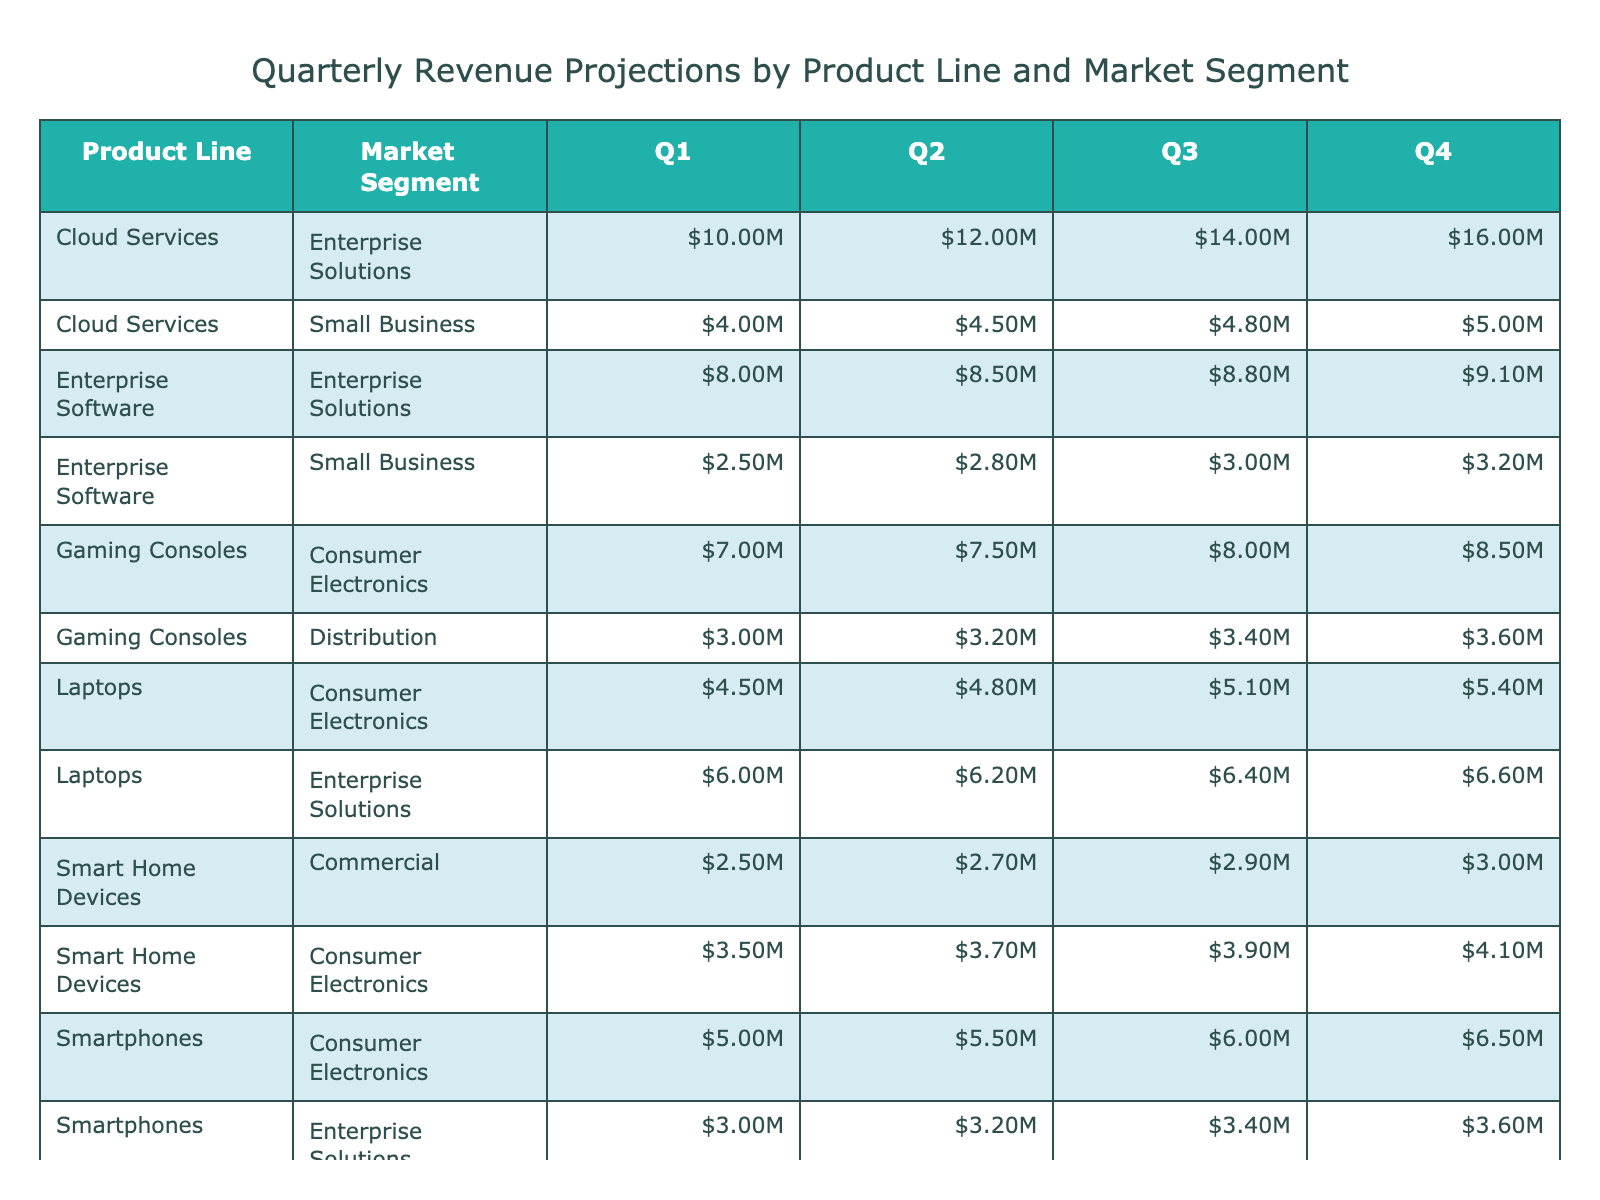What is the projected revenue for Smartphones in Q3? The table shows that the revenue for Smartphones in Q3 is listed under the respective market segments. For Consumer Electronics, it's $6.00M, and for Enterprise Solutions, it's $3.40M.
Answer: $6.00M (Consumer Electronics), $3.40M (Enterprise Solutions) Which product line has the highest total projected revenue across all quarters? To determine this, we can add the revenues for each product line across all quarters. The total revenues are: Smartphones = $23.00M, Laptops = $23.00M, Wearable Devices = $9.80M, Smart Home Devices = $9.60M, Cloud Services = $61.00M, Gaming Consoles = $33.00M, Enterprise Software = $32.00M. Cloud Services has the highest total at $61.00M.
Answer: Cloud Services Is the revenue for Wearable Devices in Q2 higher than that of Gaming Consoles in Q1? The revenue for Wearable Devices in Q2 is $2.30M, while Gaming Consoles in Q1 is $7.00M. Comparing the two, Wearable Devices’ $2.30M is less than Gaming Consoles’ $7.00M.
Answer: No What is the average projected revenue for Laptops across the four quarters? First, we sum the revenues for Laptops across the four quarters: $4.50M + $4.80M + $5.10M + $5.40M = $20.80M. Then, we divide by the number of quarters (4), resulting in an average of $5.20M.
Answer: $5.20M Which market segment contributes the least revenue for the Smart Home Devices product line? The table shows that Smart Home Devices has two market segments: Consumer Electronics with $15.70M total and Commercial with $11.80M total across all quarters. The Commercial segment contributes less.
Answer: Commercial What was the revenue difference between Q1 and Q4 for Cloud Services? For Q1, Cloud Services has a revenue of $10.00M and for Q4 it has $16.00M. The difference can be found by subtracting Q1 revenue from Q4 revenue: $16.00M - $10.00M = $6.00M.
Answer: $6.00M Do both Enterprise Solutions and Small Business have revenue projections for all four quarters? The table lists the revenues for both market segments showing that they indeed have projected revenues reported across all quarters for each product line.
Answer: Yes Which quarter had the highest projected revenue for Gaming Consoles? The table presents the quarterly revenues for Gaming Consoles: Q1 = $7.00M, Q2 = $7.50M, Q3 = $8.00M, and Q4 = $8.50M. By examining these values, Q4 has the highest at $8.50M.
Answer: Q4 What is the total projected revenue in Q3 for all product lines combined? We need to sum the revenues in Q3 for each product line. The values from the table are: Smartphones ($6.00M) + Laptops ($5.10M) + Wearable Devices ($2.60M) + Smart Home Devices ($3.90M) + Cloud Services ($14.00M) + Gaming Consoles ($8.00M) + Enterprise Software ($8.80M). The total adds up to $38.50M.
Answer: $38.50M Which product line has more revenue from the Enterprise Solutions market segment than from the Small Business segment? Observing the table, we notice that Cloud Services and Enterprise Software both have higher projected revenues from Enterprise Solutions compared to their Small Business segment revenues. Cloud Services has $40.00M vs. $20.00M, and Enterprise Software has $34.00M vs. $10.00M.
Answer: Cloud Services and Enterprise Software What is the total for the Healthcare market segment across all quarters? The Healthcare segment only has revenue from Wearable Devices, which are $1.50M in Q1, $1.50M in Q2, $1.60M in Q3, and $1.70M in Q4. Summing these gives: $1.50M + $1.50M + $1.60M + $1.70M = $6.30M.
Answer: $6.30M 